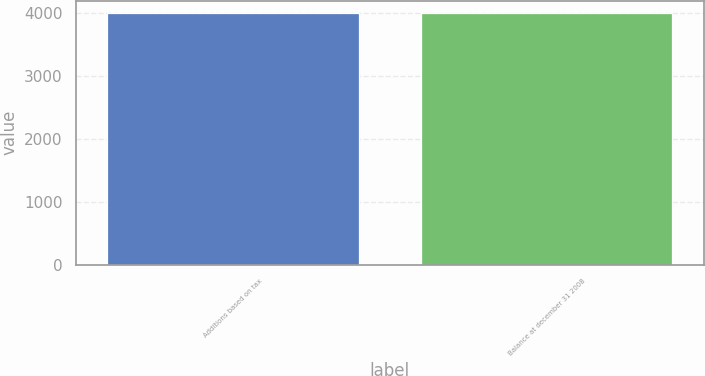<chart> <loc_0><loc_0><loc_500><loc_500><bar_chart><fcel>Additions based on tax<fcel>Balance at december 31 2008<nl><fcel>4000<fcel>4000.1<nl></chart> 